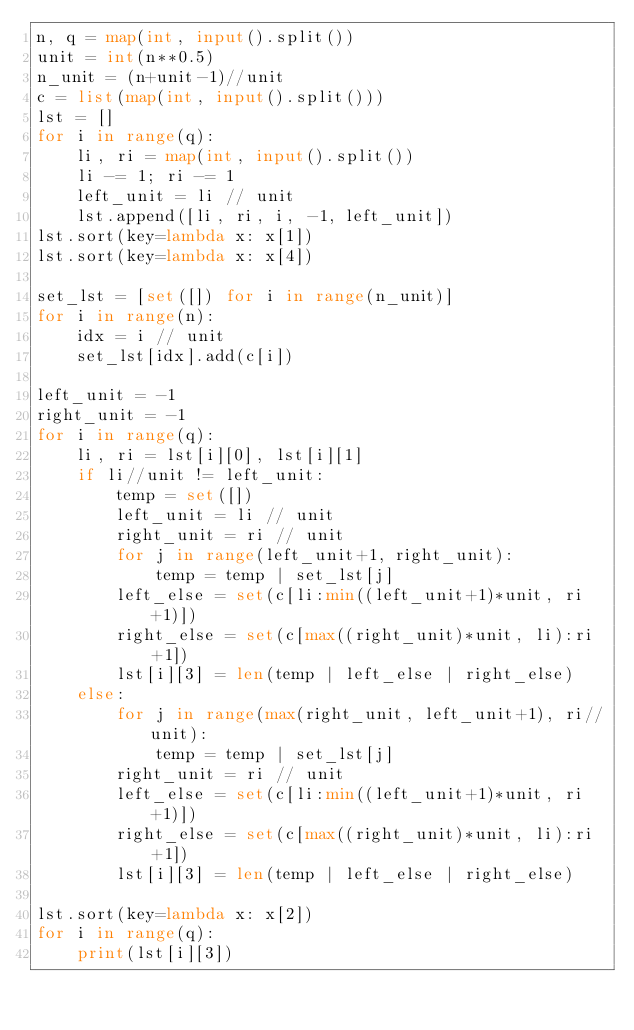<code> <loc_0><loc_0><loc_500><loc_500><_Python_>n, q = map(int, input().split())
unit = int(n**0.5)
n_unit = (n+unit-1)//unit
c = list(map(int, input().split()))
lst = []
for i in range(q):
    li, ri = map(int, input().split())
    li -= 1; ri -= 1
    left_unit = li // unit
    lst.append([li, ri, i, -1, left_unit])
lst.sort(key=lambda x: x[1])
lst.sort(key=lambda x: x[4])

set_lst = [set([]) for i in range(n_unit)]
for i in range(n):
    idx = i // unit
    set_lst[idx].add(c[i])

left_unit = -1
right_unit = -1
for i in range(q):
    li, ri = lst[i][0], lst[i][1]
    if li//unit != left_unit:
        temp = set([])
        left_unit = li // unit
        right_unit = ri // unit
        for j in range(left_unit+1, right_unit):
            temp = temp | set_lst[j]
        left_else = set(c[li:min((left_unit+1)*unit, ri+1)])
        right_else = set(c[max((right_unit)*unit, li):ri+1])
        lst[i][3] = len(temp | left_else | right_else)
    else:
        for j in range(max(right_unit, left_unit+1), ri//unit):
            temp = temp | set_lst[j]
        right_unit = ri // unit
        left_else = set(c[li:min((left_unit+1)*unit, ri+1)])
        right_else = set(c[max((right_unit)*unit, li):ri+1])
        lst[i][3] = len(temp | left_else | right_else)

lst.sort(key=lambda x: x[2])
for i in range(q):
    print(lst[i][3])</code> 